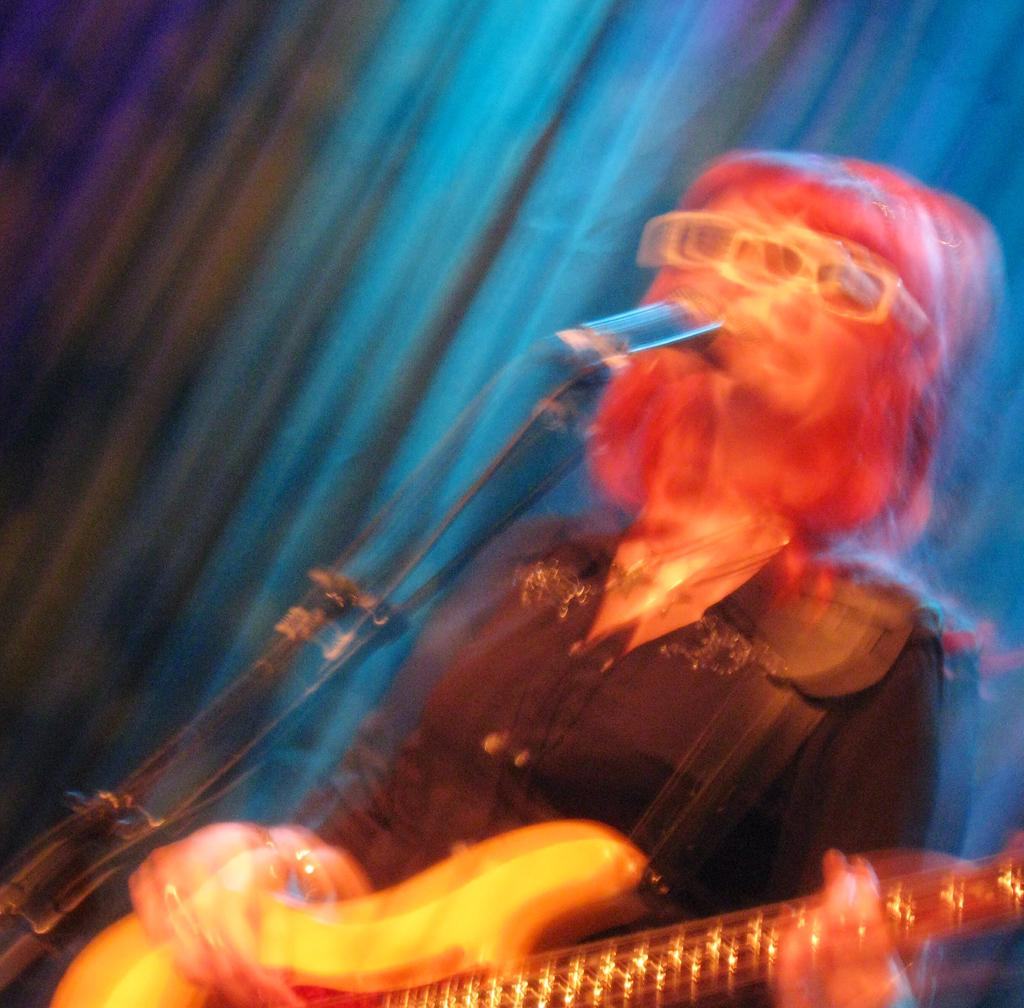What is the person in the image holding? The person is holding a guitar. What object is located near the person in the image? There is a microphone in the bottom left side of the image. Can you describe the person's position in the image? The person is standing in the bottom right side of the image. How would you describe the overall quality of the image? The image is blurry. What type of cabbage is being played in harmony by the nation in the image? There is no cabbage or nation present in the image; it features a person holding a guitar and a microphone. 